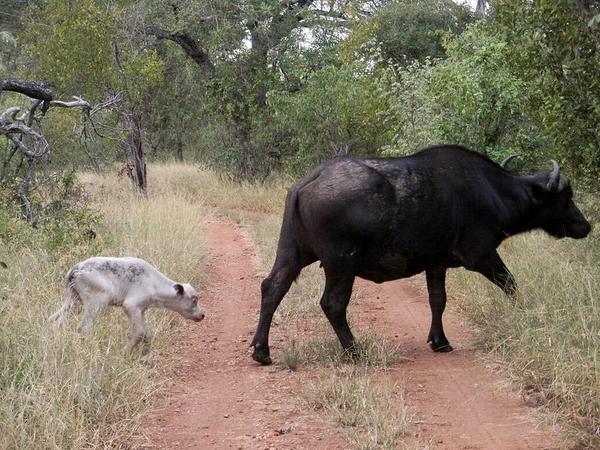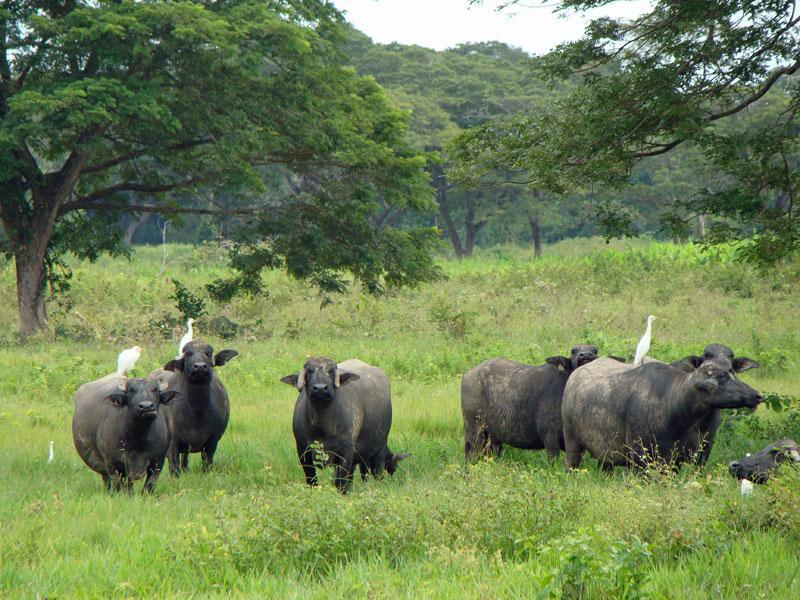The first image is the image on the left, the second image is the image on the right. Considering the images on both sides, is "In at least one image there is a longhorn bull with his face pointed forward left." valid? Answer yes or no. No. The first image is the image on the left, the second image is the image on the right. Given the left and right images, does the statement "All the animals have horns." hold true? Answer yes or no. No. 